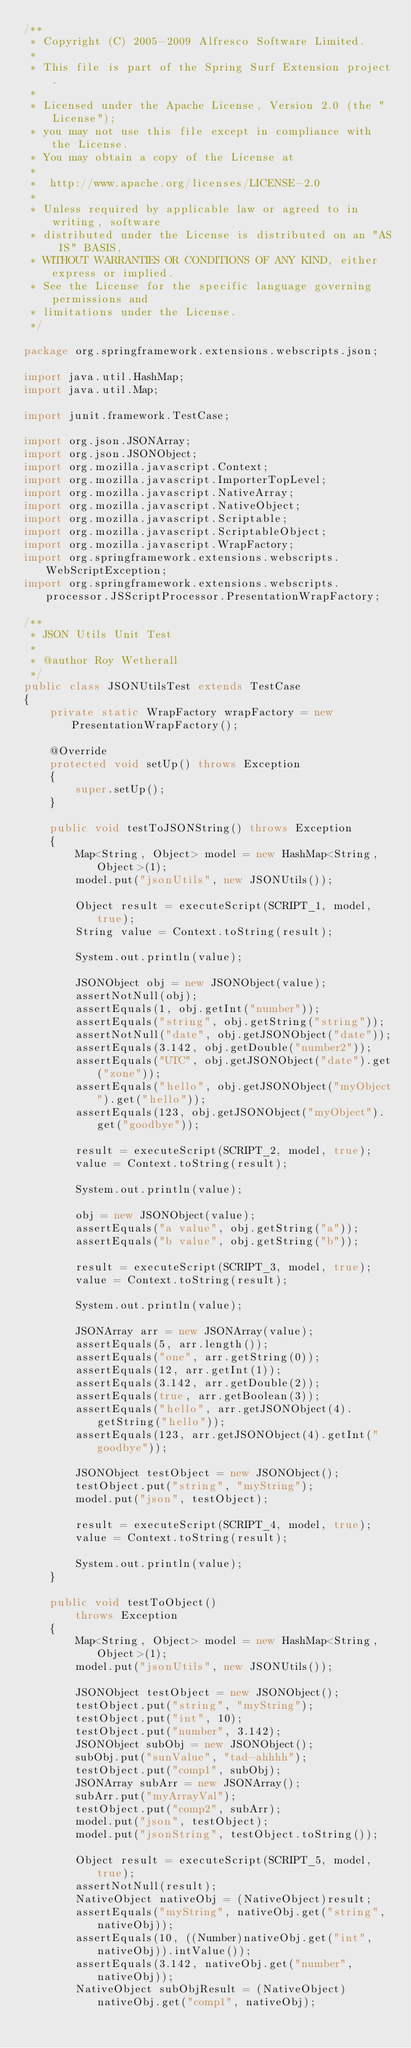Convert code to text. <code><loc_0><loc_0><loc_500><loc_500><_Java_>/**
 * Copyright (C) 2005-2009 Alfresco Software Limited.
 *
 * This file is part of the Spring Surf Extension project.
 *
 * Licensed under the Apache License, Version 2.0 (the "License");
 * you may not use this file except in compliance with the License.
 * You may obtain a copy of the License at
 *
 *  http://www.apache.org/licenses/LICENSE-2.0
 *
 * Unless required by applicable law or agreed to in writing, software
 * distributed under the License is distributed on an "AS IS" BASIS,
 * WITHOUT WARRANTIES OR CONDITIONS OF ANY KIND, either express or implied.
 * See the License for the specific language governing permissions and
 * limitations under the License.
 */

package org.springframework.extensions.webscripts.json;

import java.util.HashMap;
import java.util.Map;

import junit.framework.TestCase;

import org.json.JSONArray;
import org.json.JSONObject;
import org.mozilla.javascript.Context;
import org.mozilla.javascript.ImporterTopLevel;
import org.mozilla.javascript.NativeArray;
import org.mozilla.javascript.NativeObject;
import org.mozilla.javascript.Scriptable;
import org.mozilla.javascript.ScriptableObject;
import org.mozilla.javascript.WrapFactory;
import org.springframework.extensions.webscripts.WebScriptException;
import org.springframework.extensions.webscripts.processor.JSScriptProcessor.PresentationWrapFactory;

/**
 * JSON Utils Unit Test
 * 
 * @author Roy Wetherall
 */
public class JSONUtilsTest extends TestCase
{
    private static WrapFactory wrapFactory = new PresentationWrapFactory(); 
    
    @Override
    protected void setUp() throws Exception
    {
        super.setUp();
    }
    
    public void testToJSONString() throws Exception
    {
        Map<String, Object> model = new HashMap<String, Object>(1);
        model.put("jsonUtils", new JSONUtils());
        
        Object result = executeScript(SCRIPT_1, model, true);
        String value = Context.toString(result);
        
        System.out.println(value);
        
        JSONObject obj = new JSONObject(value);
        assertNotNull(obj);
        assertEquals(1, obj.getInt("number"));
        assertEquals("string", obj.getString("string"));
        assertNotNull("date", obj.getJSONObject("date"));
        assertEquals(3.142, obj.getDouble("number2"));
        assertEquals("UTC", obj.getJSONObject("date").get("zone"));
        assertEquals("hello", obj.getJSONObject("myObject").get("hello"));
        assertEquals(123, obj.getJSONObject("myObject").get("goodbye"));
        
        result = executeScript(SCRIPT_2, model, true);
        value = Context.toString(result);
        
        System.out.println(value);
        
        obj = new JSONObject(value);
        assertEquals("a value", obj.getString("a"));
        assertEquals("b value", obj.getString("b"));
        
        result = executeScript(SCRIPT_3, model, true);
        value = Context.toString(result);
        
        System.out.println(value);
        
        JSONArray arr = new JSONArray(value);
        assertEquals(5, arr.length());
        assertEquals("one", arr.getString(0));
        assertEquals(12, arr.getInt(1));
        assertEquals(3.142, arr.getDouble(2));
        assertEquals(true, arr.getBoolean(3));
        assertEquals("hello", arr.getJSONObject(4).getString("hello"));
        assertEquals(123, arr.getJSONObject(4).getInt("goodbye"));
        
        JSONObject testObject = new JSONObject();
        testObject.put("string", "myString");
        model.put("json", testObject);        
        
        result = executeScript(SCRIPT_4, model, true);
        value = Context.toString(result);
        
        System.out.println(value);
    }
    
    public void testToObject()
        throws Exception
    {
        Map<String, Object> model = new HashMap<String, Object>(1);
        model.put("jsonUtils", new JSONUtils());
        
        JSONObject testObject = new JSONObject();
        testObject.put("string", "myString");
        testObject.put("int", 10);
        testObject.put("number", 3.142);
        JSONObject subObj = new JSONObject();
        subObj.put("sunValue", "tad-ahhhh");
        testObject.put("comp1", subObj);
        JSONArray subArr = new JSONArray();
        subArr.put("myArrayVal");
        testObject.put("comp2", subArr);
        model.put("json", testObject); 
        model.put("jsonString", testObject.toString());        
        
        Object result = executeScript(SCRIPT_5, model, true);
        assertNotNull(result);
        NativeObject nativeObj = (NativeObject)result;
        assertEquals("myString", nativeObj.get("string", nativeObj));
        assertEquals(10, ((Number)nativeObj.get("int", nativeObj)).intValue());
        assertEquals(3.142, nativeObj.get("number", nativeObj));
        NativeObject subObjResult = (NativeObject)nativeObj.get("comp1", nativeObj);</code> 